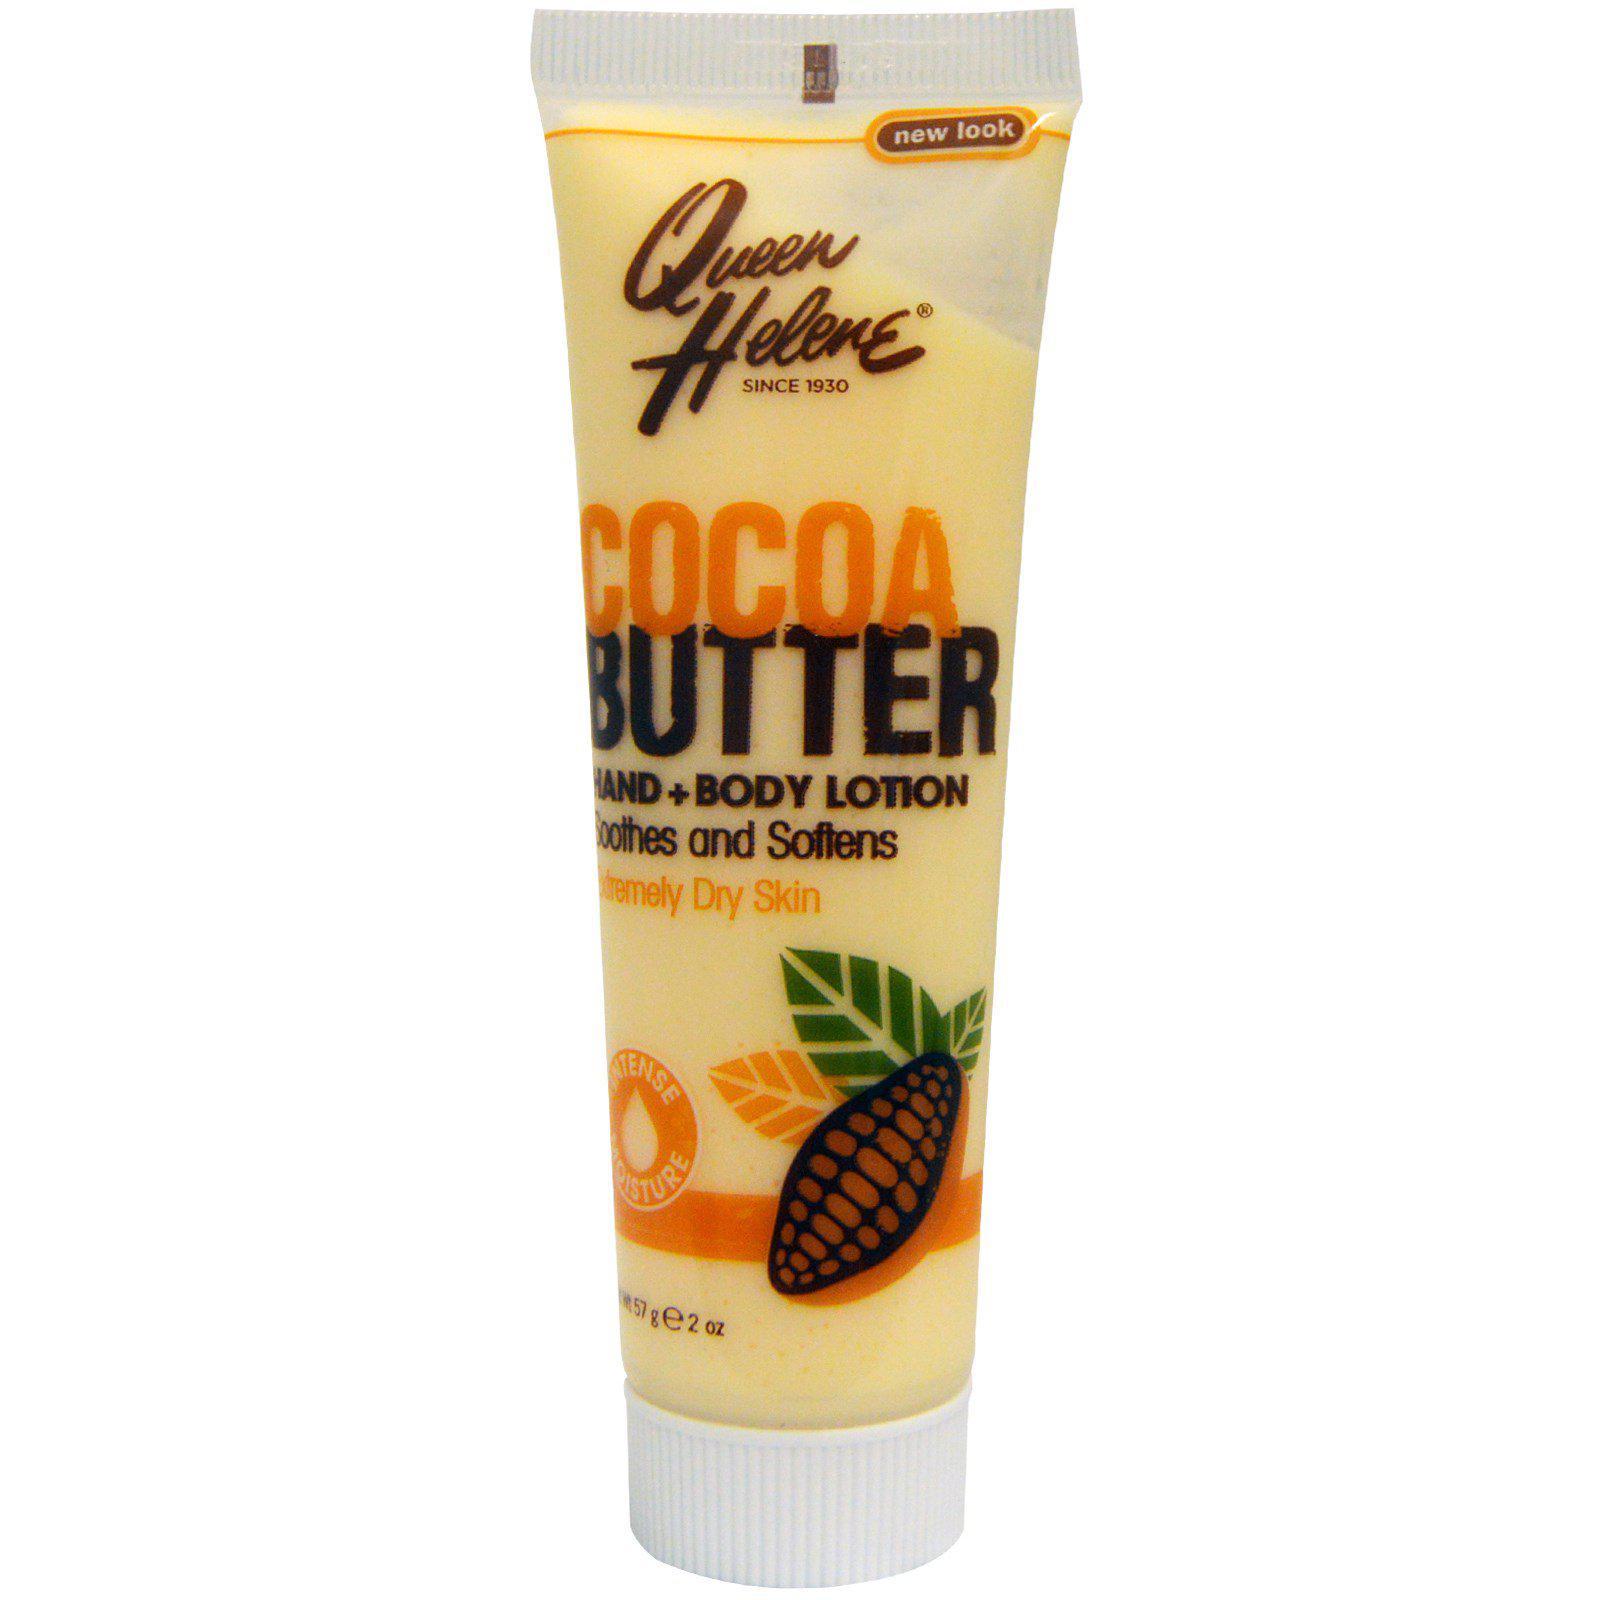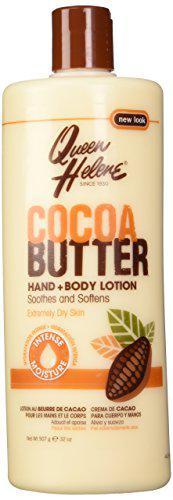The first image is the image on the left, the second image is the image on the right. For the images displayed, is the sentence "Left image contains no more than 2 lotion products." factually correct? Answer yes or no. Yes. The first image is the image on the left, the second image is the image on the right. Analyze the images presented: Is the assertion "The items in the image on the left are on surfaces of the same color." valid? Answer yes or no. No. 